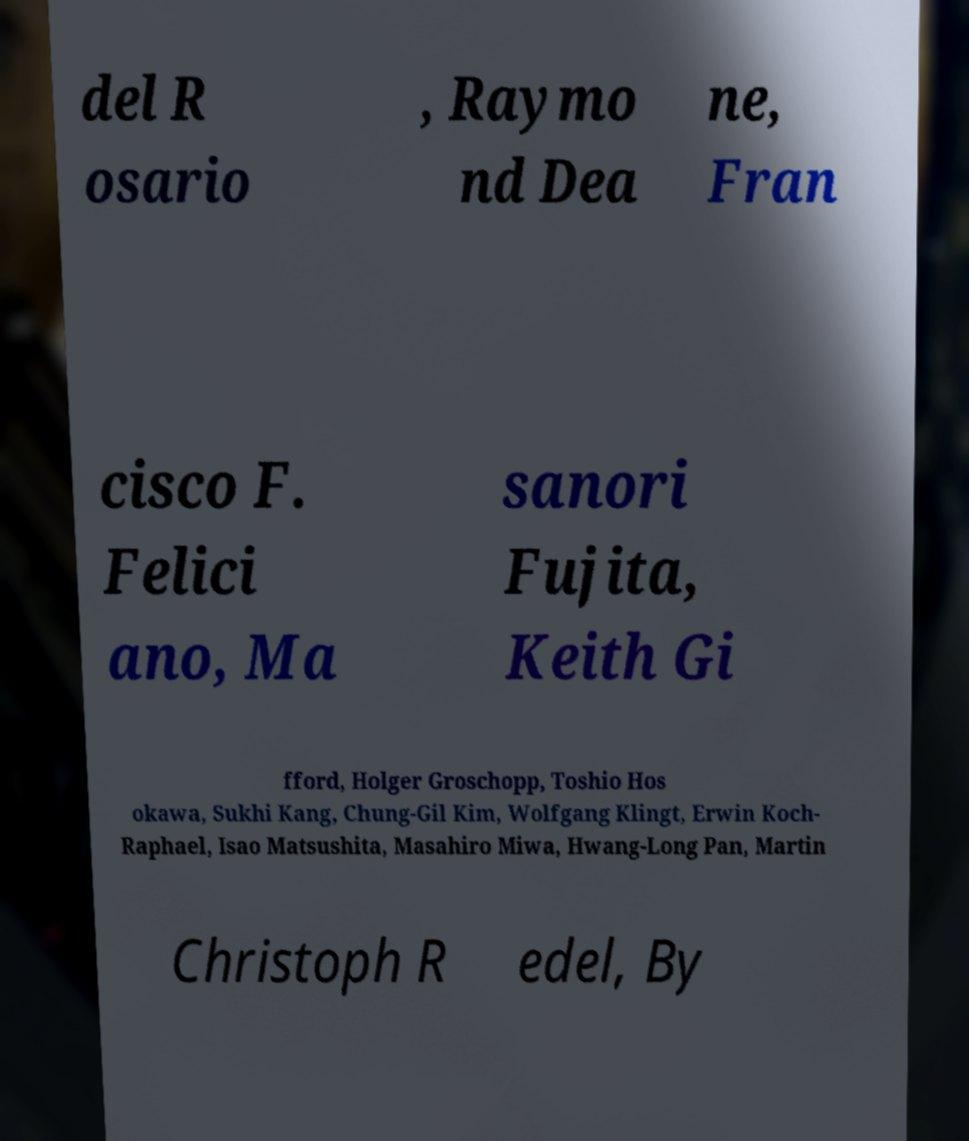Please read and relay the text visible in this image. What does it say? del R osario , Raymo nd Dea ne, Fran cisco F. Felici ano, Ma sanori Fujita, Keith Gi fford, Holger Groschopp, Toshio Hos okawa, Sukhi Kang, Chung-Gil Kim, Wolfgang Klingt, Erwin Koch- Raphael, Isao Matsushita, Masahiro Miwa, Hwang-Long Pan, Martin Christoph R edel, By 